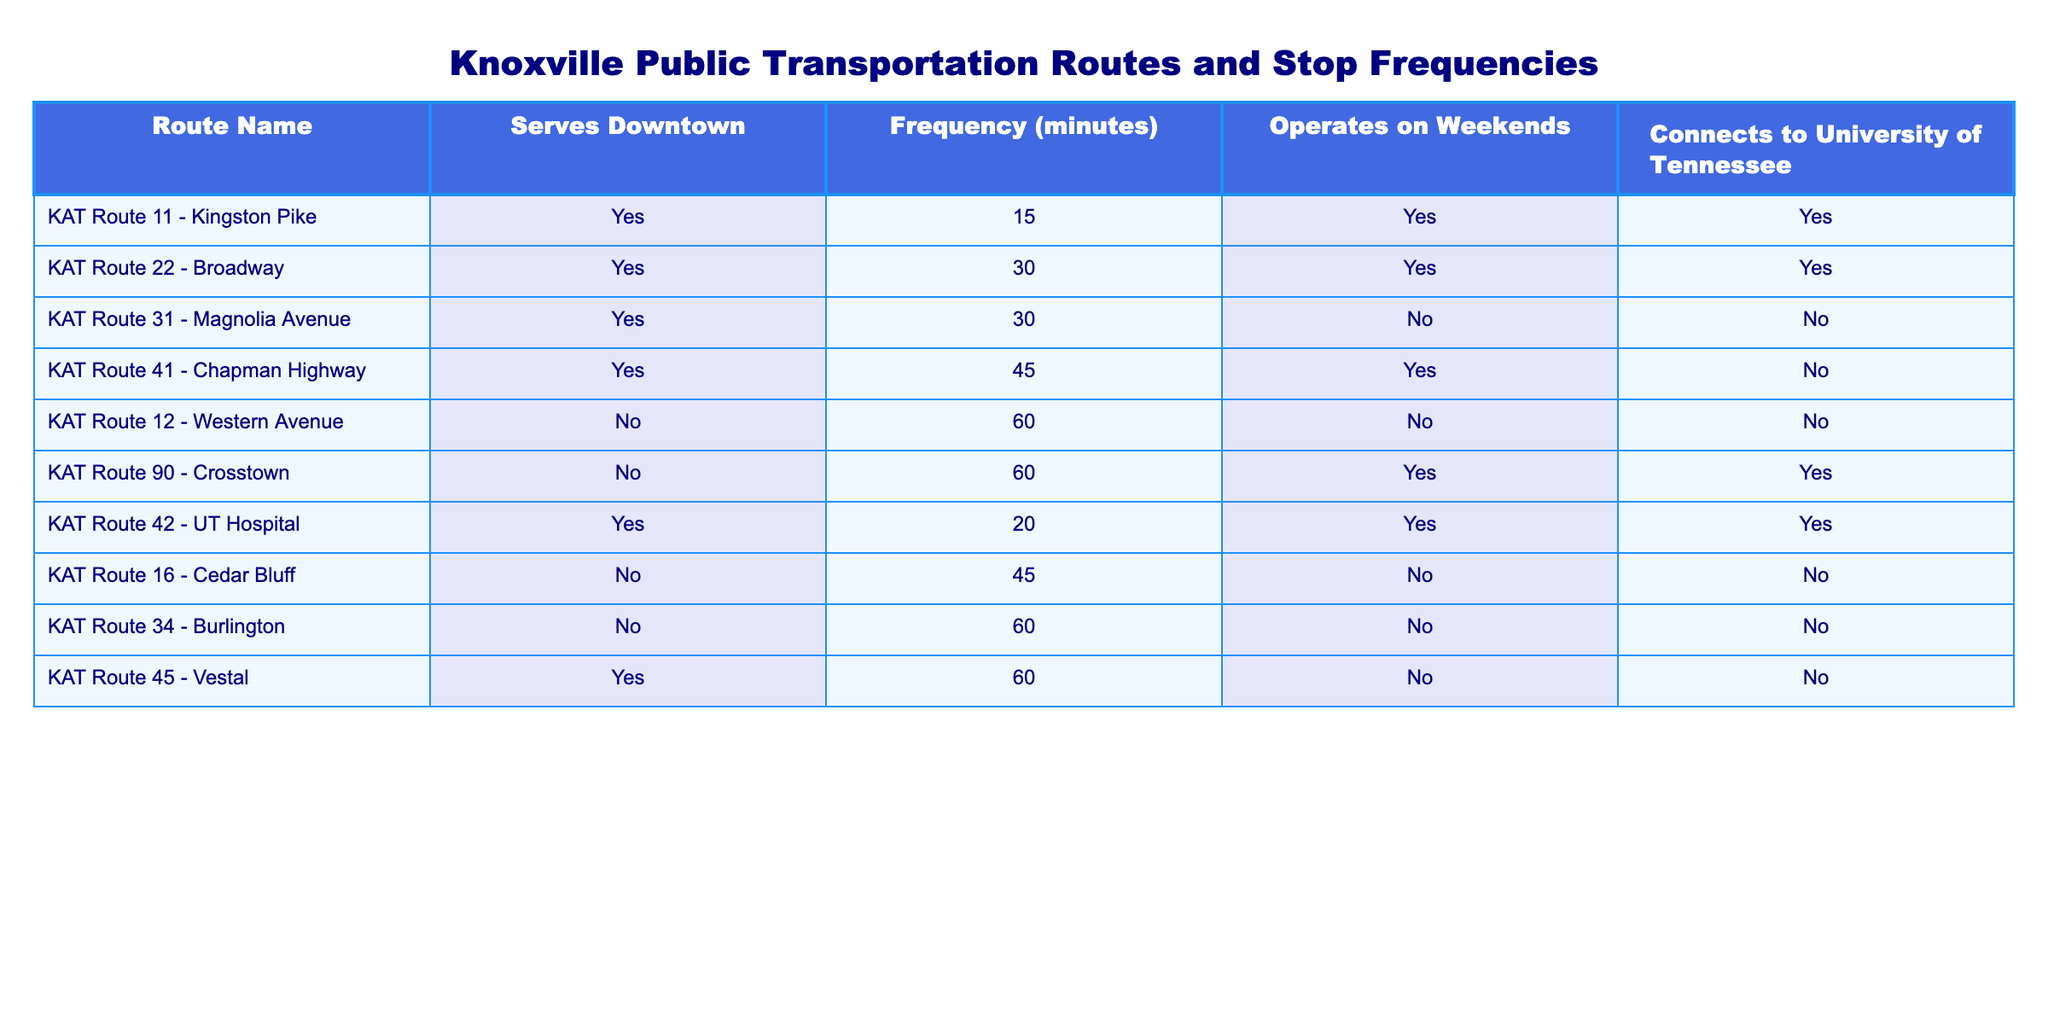What route connects to the University of Tennessee and operates on weekends? To find the routes that connect to the University of Tennessee and operate on weekends, we look at the corresponding columns for both conditions. The routes that meet both criteria are "KAT Route 11 - Kingston Pike", "KAT Route 22 - Broadway", and "KAT Route 42 - UT Hospital".
Answer: KAT Route 11 - Kingston Pike, KAT Route 22 - Broadway, KAT Route 42 - UT Hospital Which route has the highest frequency in minutes? To identify the route with the highest frequency, we check the "Frequency (minutes)" column for the maximum value. The highest frequency shown is 60 minutes, and the routes that have this frequency are "KAT Route 12 - Western Avenue", "KAT Route 90 - Crosstown", and "KAT Route 34 - Burlington".
Answer: KAT Route 12 - Western Avenue, KAT Route 90 - Crosstown, KAT Route 34 - Burlington Do any routes serve downtown and operate on weekends? We look for routes that have "Yes" in both the "Serves Downtown" and "Operates on Weekends" columns. The routes that meet these criteria are "KAT Route 11 - Kingston Pike", "KAT Route 22 - Broadway", and "KAT Route 42 - UT Hospital".
Answer: Yes What is the average frequency of routes that do not serve downtown? For routes that do not serve downtown, the frequencies are 60, 60, and 60 minutes for "KAT Route 12 - Western Avenue", "KAT Route 90 - Crosstown", and "KAT Route 34 - Burlington". The sum of these frequencies is 60 + 60 + 60 = 180 minutes, and since there are 3 routes, the average frequency is 180 / 3 = 60 minutes.
Answer: 60 How many routes have a frequency less than 30 minutes? We examine the "Frequency (minutes)" column to find out how many routes have a frequency of less than 30 minutes. From the table, the only route that meets this condition is "KAT Route 42 - UT Hospital", with a frequency of 20 minutes. Hence, there's only one route.
Answer: 1 